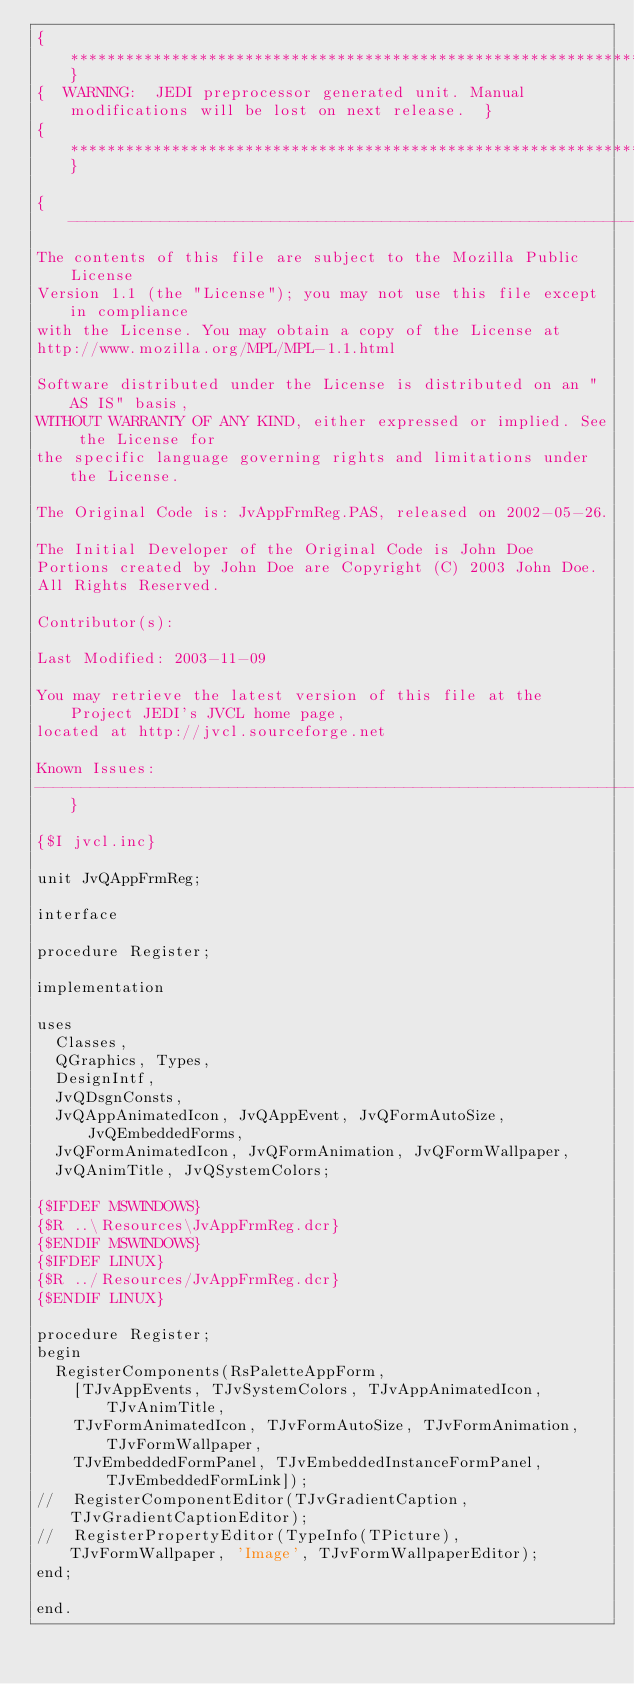Convert code to text. <code><loc_0><loc_0><loc_500><loc_500><_Pascal_>{**************************************************************************************************}
{  WARNING:  JEDI preprocessor generated unit. Manual modifications will be lost on next release.  }
{**************************************************************************************************}

{-----------------------------------------------------------------------------
The contents of this file are subject to the Mozilla Public License
Version 1.1 (the "License"); you may not use this file except in compliance
with the License. You may obtain a copy of the License at
http://www.mozilla.org/MPL/MPL-1.1.html

Software distributed under the License is distributed on an "AS IS" basis,
WITHOUT WARRANTY OF ANY KIND, either expressed or implied. See the License for
the specific language governing rights and limitations under the License.

The Original Code is: JvAppFrmReg.PAS, released on 2002-05-26.

The Initial Developer of the Original Code is John Doe
Portions created by John Doe are Copyright (C) 2003 John Doe.
All Rights Reserved.

Contributor(s):

Last Modified: 2003-11-09

You may retrieve the latest version of this file at the Project JEDI's JVCL home page,
located at http://jvcl.sourceforge.net

Known Issues:
-----------------------------------------------------------------------------}

{$I jvcl.inc}

unit JvQAppFrmReg;

interface

procedure Register;

implementation

uses
  Classes,
  QGraphics, Types,
  DesignIntf,
  JvQDsgnConsts,
  JvQAppAnimatedIcon, JvQAppEvent, JvQFormAutoSize, JvQEmbeddedForms,
  JvQFormAnimatedIcon, JvQFormAnimation, JvQFormWallpaper,
  JvQAnimTitle, JvQSystemColors;

{$IFDEF MSWINDOWS}
{$R ..\Resources\JvAppFrmReg.dcr}
{$ENDIF MSWINDOWS}
{$IFDEF LINUX}
{$R ../Resources/JvAppFrmReg.dcr}
{$ENDIF LINUX}

procedure Register;
begin
  RegisterComponents(RsPaletteAppForm,
    [TJvAppEvents, TJvSystemColors, TJvAppAnimatedIcon, TJvAnimTitle,
    TJvFormAnimatedIcon, TJvFormAutoSize, TJvFormAnimation, TJvFormWallpaper,
    TJvEmbeddedFormPanel, TJvEmbeddedInstanceFormPanel, TJvEmbeddedFormLink]);
//  RegisterComponentEditor(TJvGradientCaption, TJvGradientCaptionEditor);
//  RegisterPropertyEditor(TypeInfo(TPicture), TJvFormWallpaper, 'Image', TJvFormWallpaperEditor);
end;

end.

</code> 